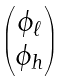Convert formula to latex. <formula><loc_0><loc_0><loc_500><loc_500>\begin{pmatrix} \phi _ { \ell } \\ \phi _ { h } \end{pmatrix}</formula> 